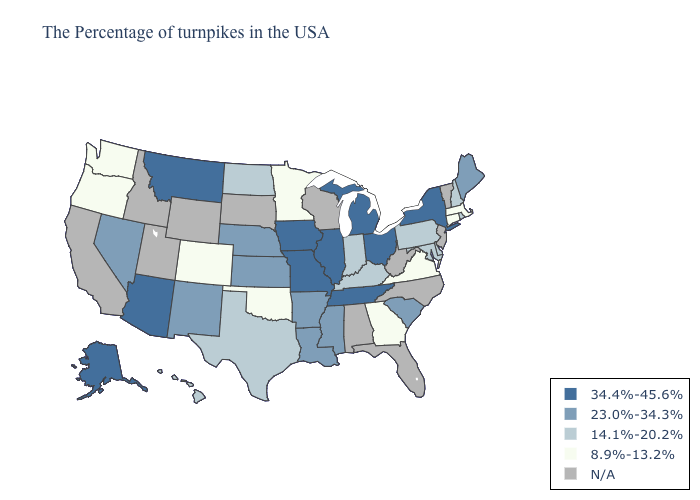Name the states that have a value in the range 8.9%-13.2%?
Be succinct. Massachusetts, Connecticut, Virginia, Georgia, Minnesota, Oklahoma, Colorado, Washington, Oregon. Which states hav the highest value in the West?
Give a very brief answer. Montana, Arizona, Alaska. Does Arizona have the lowest value in the USA?
Be succinct. No. Name the states that have a value in the range 34.4%-45.6%?
Be succinct. New York, Ohio, Michigan, Tennessee, Illinois, Missouri, Iowa, Montana, Arizona, Alaska. Name the states that have a value in the range N/A?
Answer briefly. Vermont, New Jersey, North Carolina, West Virginia, Florida, Alabama, Wisconsin, South Dakota, Wyoming, Utah, Idaho, California. Is the legend a continuous bar?
Quick response, please. No. What is the value of Virginia?
Be succinct. 8.9%-13.2%. Among the states that border North Carolina , which have the highest value?
Short answer required. Tennessee. What is the value of Florida?
Quick response, please. N/A. What is the highest value in states that border Texas?
Keep it brief. 23.0%-34.3%. What is the value of Oregon?
Give a very brief answer. 8.9%-13.2%. Name the states that have a value in the range N/A?
Short answer required. Vermont, New Jersey, North Carolina, West Virginia, Florida, Alabama, Wisconsin, South Dakota, Wyoming, Utah, Idaho, California. Which states hav the highest value in the South?
Give a very brief answer. Tennessee. What is the value of Colorado?
Give a very brief answer. 8.9%-13.2%. Does Georgia have the highest value in the USA?
Write a very short answer. No. 